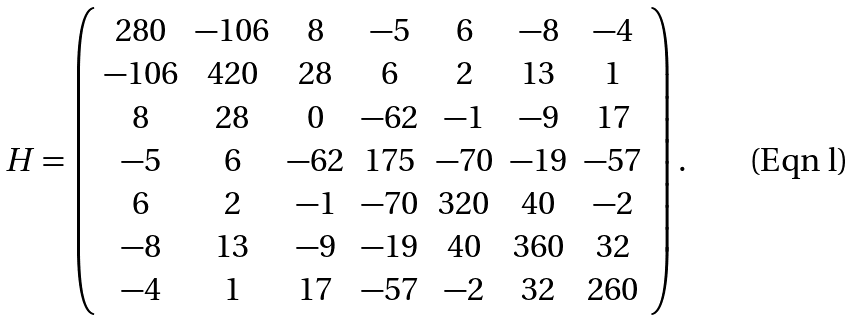Convert formula to latex. <formula><loc_0><loc_0><loc_500><loc_500>H = \left ( \begin{array} { c c c c c c c } 2 8 0 & - 1 0 6 & 8 & - 5 & 6 & - 8 & - 4 \\ - 1 0 6 & 4 2 0 & 2 8 & 6 & 2 & 1 3 & 1 \\ 8 & 2 8 & 0 & - 6 2 & - 1 & - 9 & 1 7 \\ - 5 & 6 & - 6 2 & 1 7 5 & - 7 0 & - 1 9 & - 5 7 \\ 6 & 2 & - 1 & - 7 0 & 3 2 0 & 4 0 & - 2 \\ - 8 & 1 3 & - 9 & - 1 9 & 4 0 & 3 6 0 & 3 2 \\ - 4 & 1 & 1 7 & - 5 7 & - 2 & 3 2 & 2 6 0 \end{array} \right ) .</formula> 